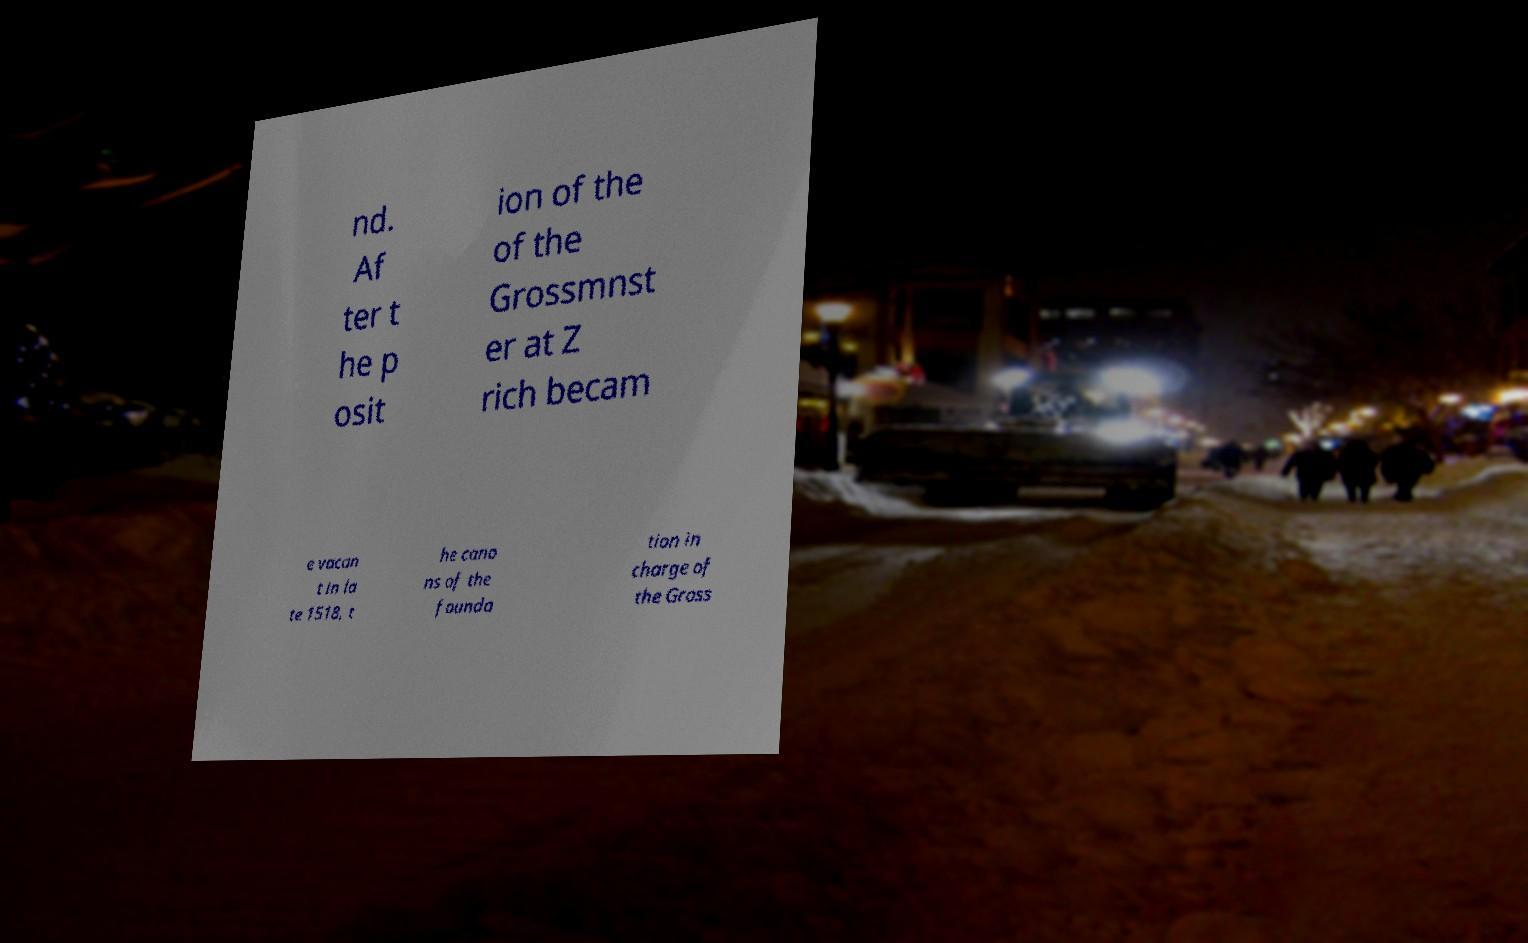Could you extract and type out the text from this image? nd. Af ter t he p osit ion of the of the Grossmnst er at Z rich becam e vacan t in la te 1518, t he cano ns of the founda tion in charge of the Gross 